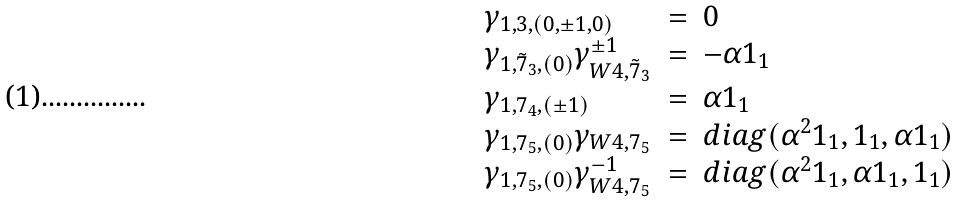<formula> <loc_0><loc_0><loc_500><loc_500>\begin{array} { l l l } \gamma _ { 1 , 3 , ( 0 , \pm 1 , 0 ) } & = & { 0 } \\ \gamma _ { 1 , { \tilde { 7 } } _ { 3 } , ( 0 ) } \gamma ^ { \pm 1 } _ { W 4 , { \tilde { 7 } } _ { 3 } } & = & - \alpha { 1 } _ { 1 } \\ \gamma _ { 1 , 7 _ { 4 } , ( \pm 1 ) } & = & \alpha { 1 } _ { 1 } \\ \gamma _ { 1 , 7 _ { 5 } , ( 0 ) } \gamma _ { W 4 , 7 _ { 5 } } & = & d i a g ( \alpha ^ { 2 } { 1 } _ { 1 } , { 1 } _ { 1 } , \alpha { 1 } _ { 1 } ) \\ \gamma _ { 1 , 7 _ { 5 } , ( 0 ) } \gamma ^ { - 1 } _ { W 4 , 7 _ { 5 } } & = & d i a g ( \alpha ^ { 2 } { 1 } _ { 1 } , \alpha { 1 } _ { 1 } , { 1 } _ { 1 } ) \end{array}</formula> 